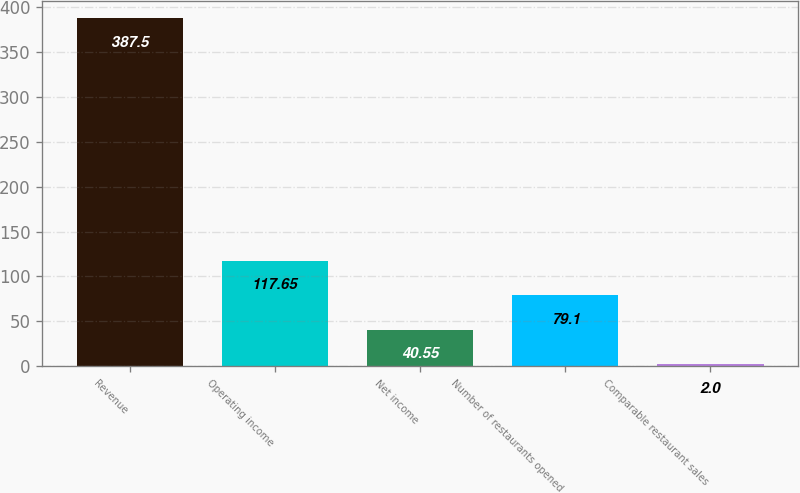Convert chart. <chart><loc_0><loc_0><loc_500><loc_500><bar_chart><fcel>Revenue<fcel>Operating income<fcel>Net income<fcel>Number of restaurants opened<fcel>Comparable restaurant sales<nl><fcel>387.5<fcel>117.65<fcel>40.55<fcel>79.1<fcel>2<nl></chart> 